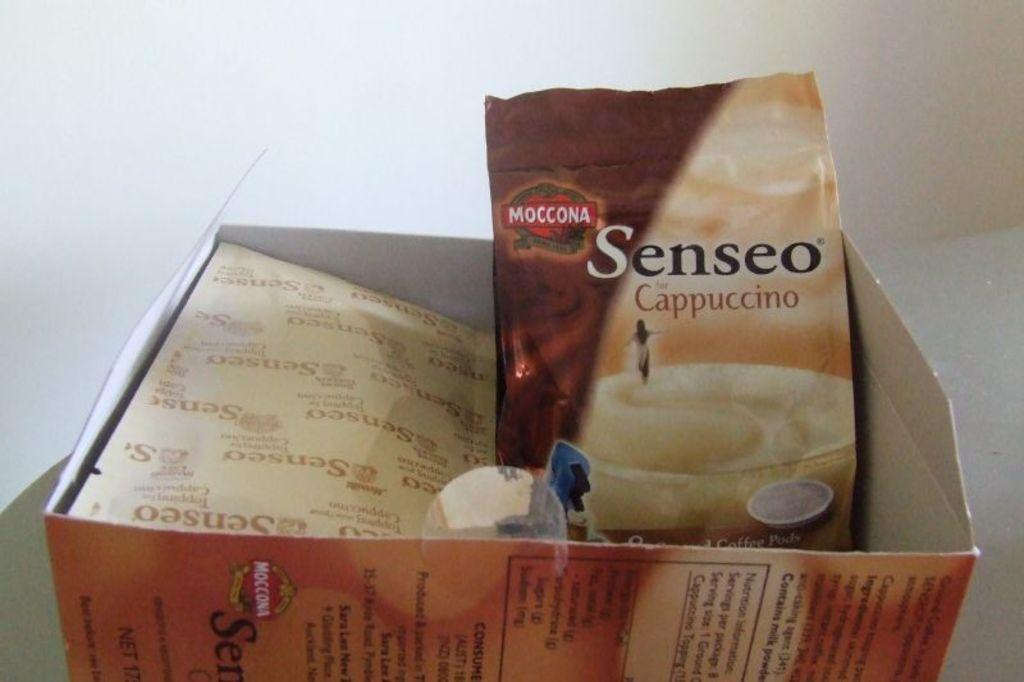Provide a one-sentence caption for the provided image. a Senseo Cappuccino coffee mix in an opened box. 